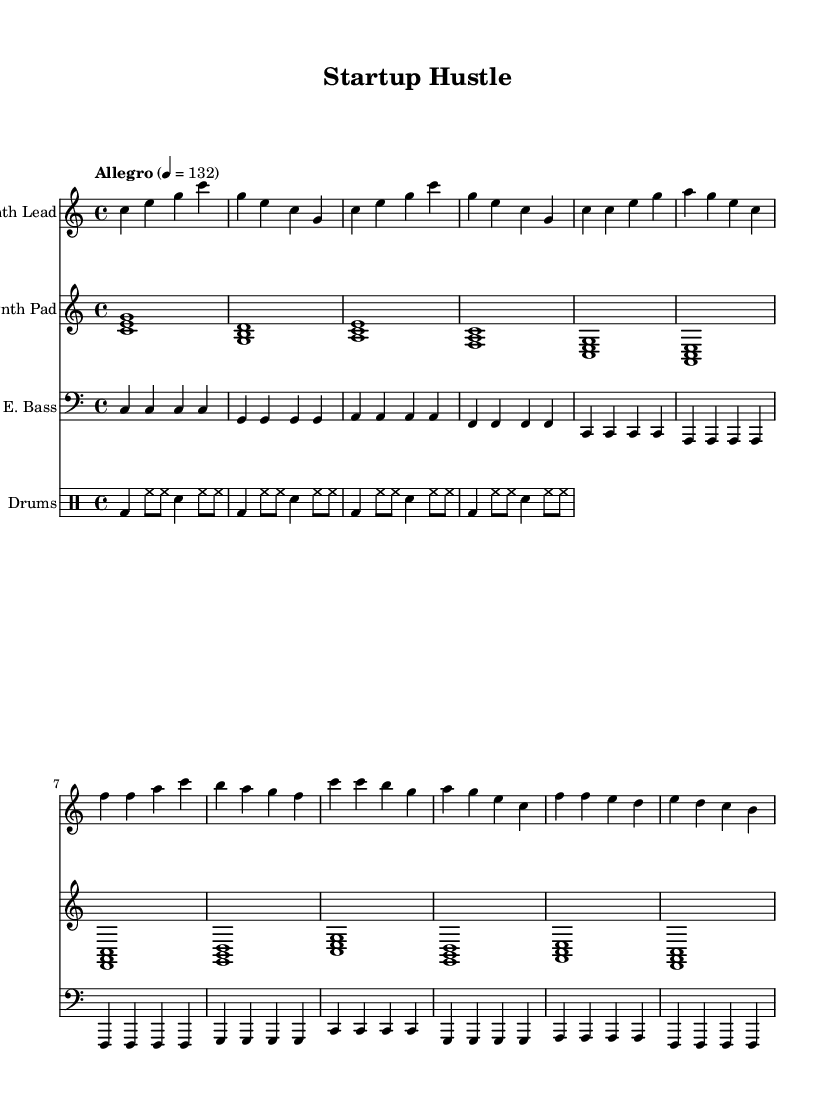What is the key signature of this music? The key signature is C major, which has no sharps or flats.
Answer: C major What is the time signature of this music? The time signature indicated in the music is 4/4, which means there are four beats in a measure.
Answer: 4/4 What is the tempo marking of this music? The tempo marking written in the score is "Allegro" with a metronome marking of 132 beats per minute.
Answer: Allegro, 132 How many measures are in the intro section? The intro consists of four measures, each represented by the corresponding notation before transitioning into the verse.
Answer: 4 What is the main rhythmic pattern used in the drum section? The drum pattern alternates between bass drum and hi-hat with snare hits, creating a driving beat typical in electronic music.
Answer: Bass, hi-hat, snare Which instrument plays the lead melody? The lead melody is played by the synth lead, as indicated at the top of that staff.
Answer: Synth Lead How does the verse differ from the chorus in terms of melodic notes? The verse mainly utilizes lower notes within the C major scale while the chorus introduces higher notes which create a more uplifting feel.
Answer: Lower notes to higher notes 